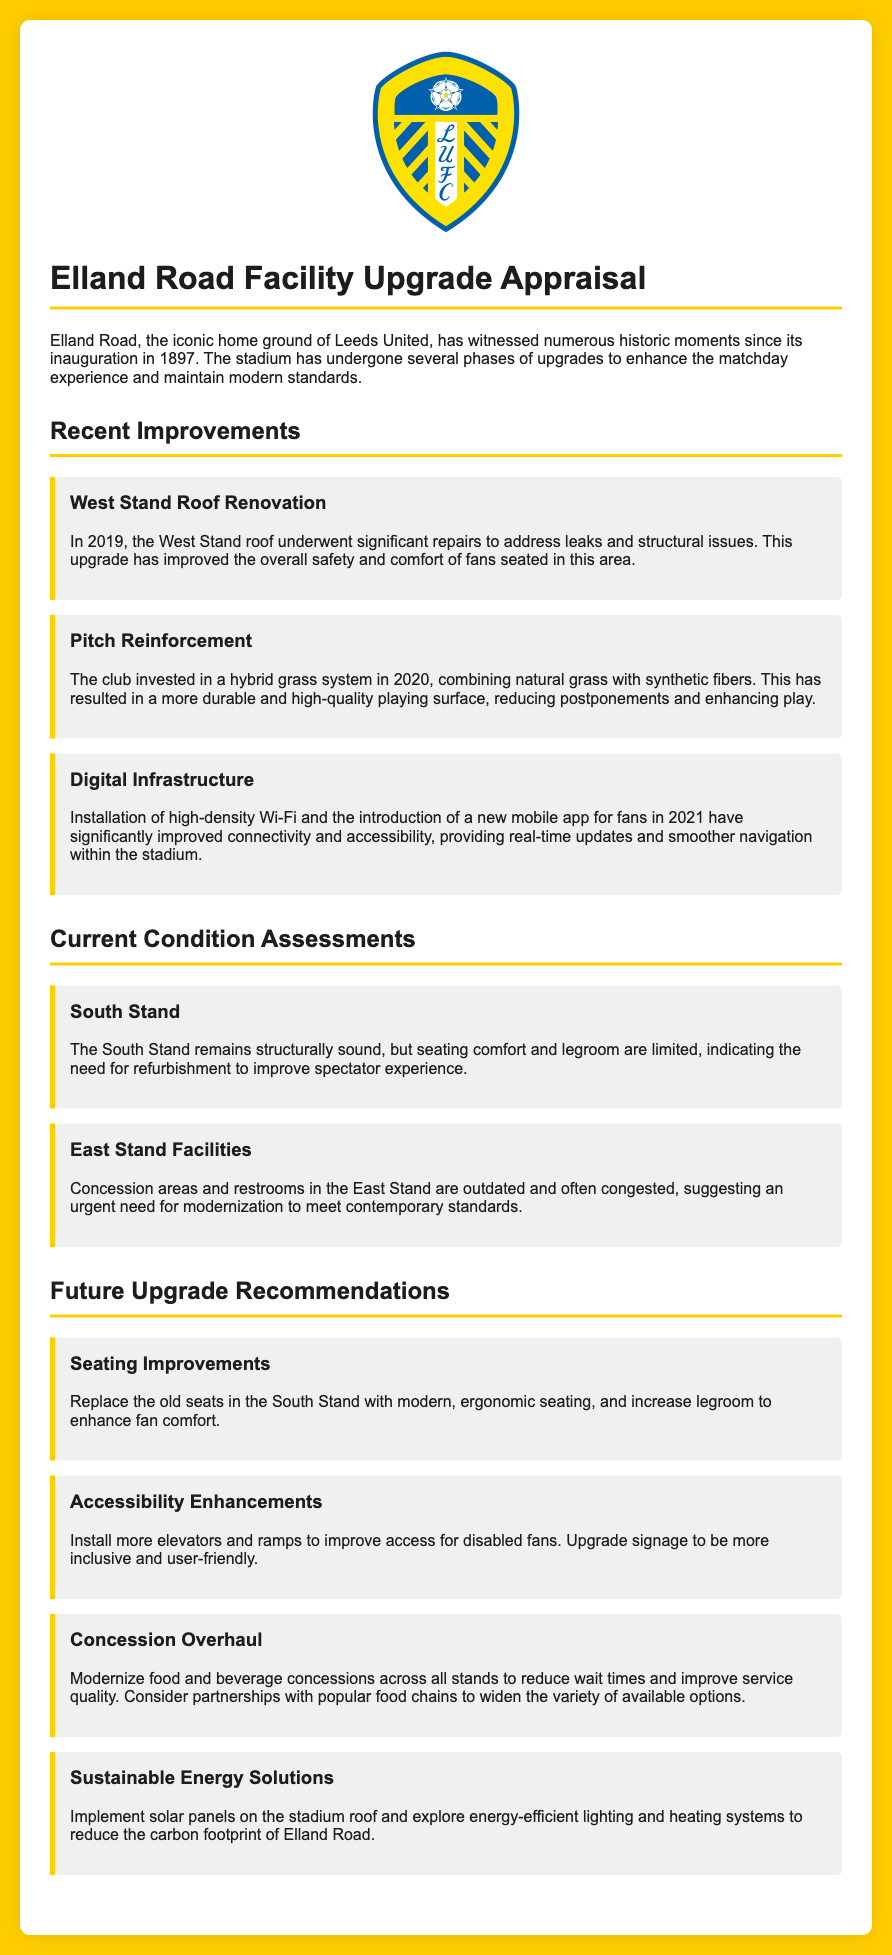what year was the West Stand roof renovated? The document states that the West Stand roof underwent significant repairs in 2019, addressing leaks and structural issues.
Answer: 2019 what type of grass system was implemented in 2020? The document mentions that the club invested in a hybrid grass system combining natural grass with synthetic fibers in 2020.
Answer: hybrid grass system what is the main issue with the East Stand facilities? The document notes that concession areas and restrooms in the East Stand are outdated and often congested.
Answer: outdated and congested how many recommendations are provided for future upgrades? The document outlines four recommendations for future upgrades at Elland Road.
Answer: four what is one suggested seating improvement? The recommendation includes replacing the old seats in the South Stand with modern, ergonomic seating.
Answer: modern, ergonomic seating what is one of the accessibility enhancements recommended? The document suggests installing more elevators and ramps to improve access for disabled fans.
Answer: more elevators and ramps which upgrade aimed at sustainability is mentioned? The document recommends implementing solar panels on the stadium roof to reduce Elland Road's carbon footprint.
Answer: solar panels 